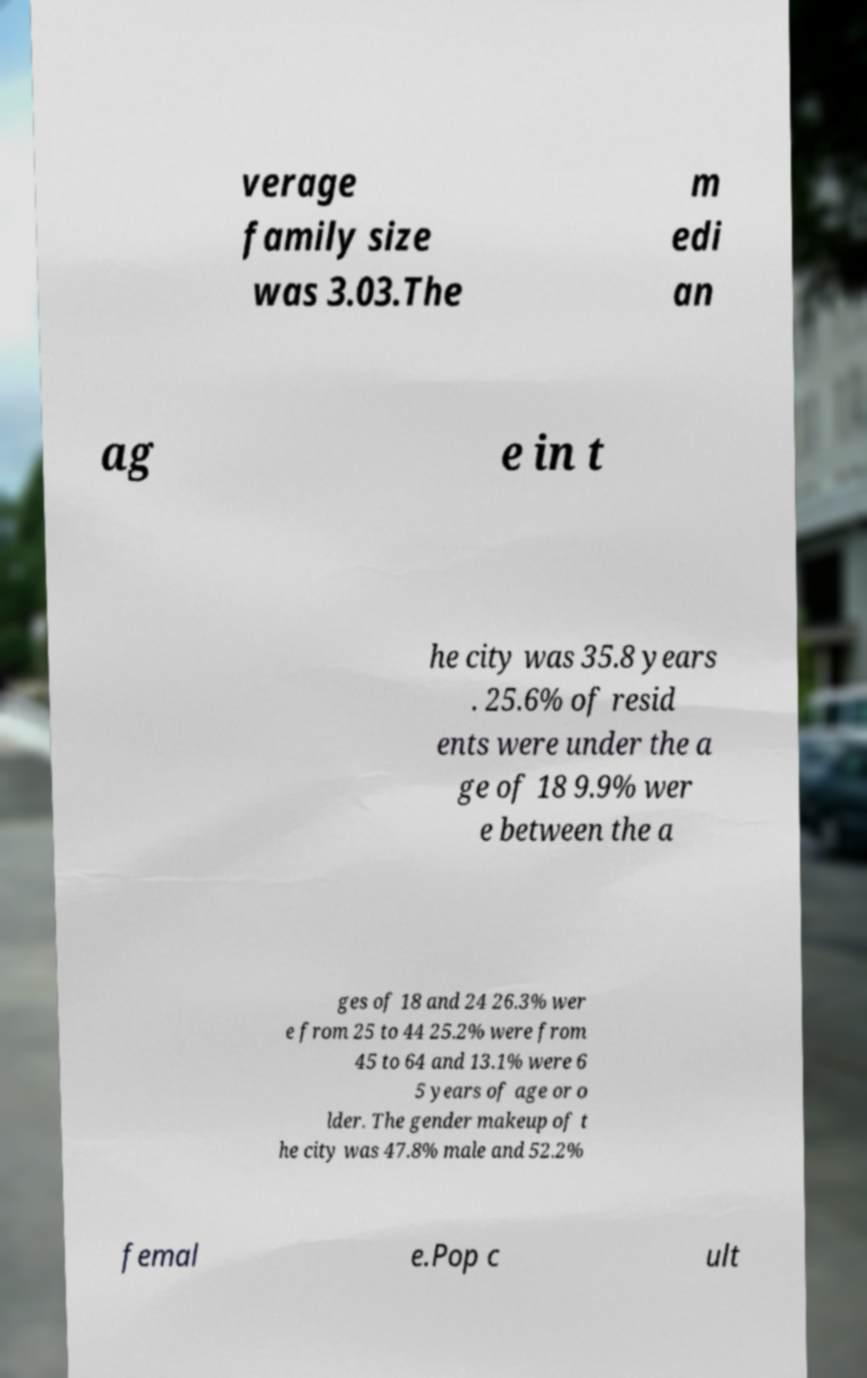For documentation purposes, I need the text within this image transcribed. Could you provide that? verage family size was 3.03.The m edi an ag e in t he city was 35.8 years . 25.6% of resid ents were under the a ge of 18 9.9% wer e between the a ges of 18 and 24 26.3% wer e from 25 to 44 25.2% were from 45 to 64 and 13.1% were 6 5 years of age or o lder. The gender makeup of t he city was 47.8% male and 52.2% femal e.Pop c ult 